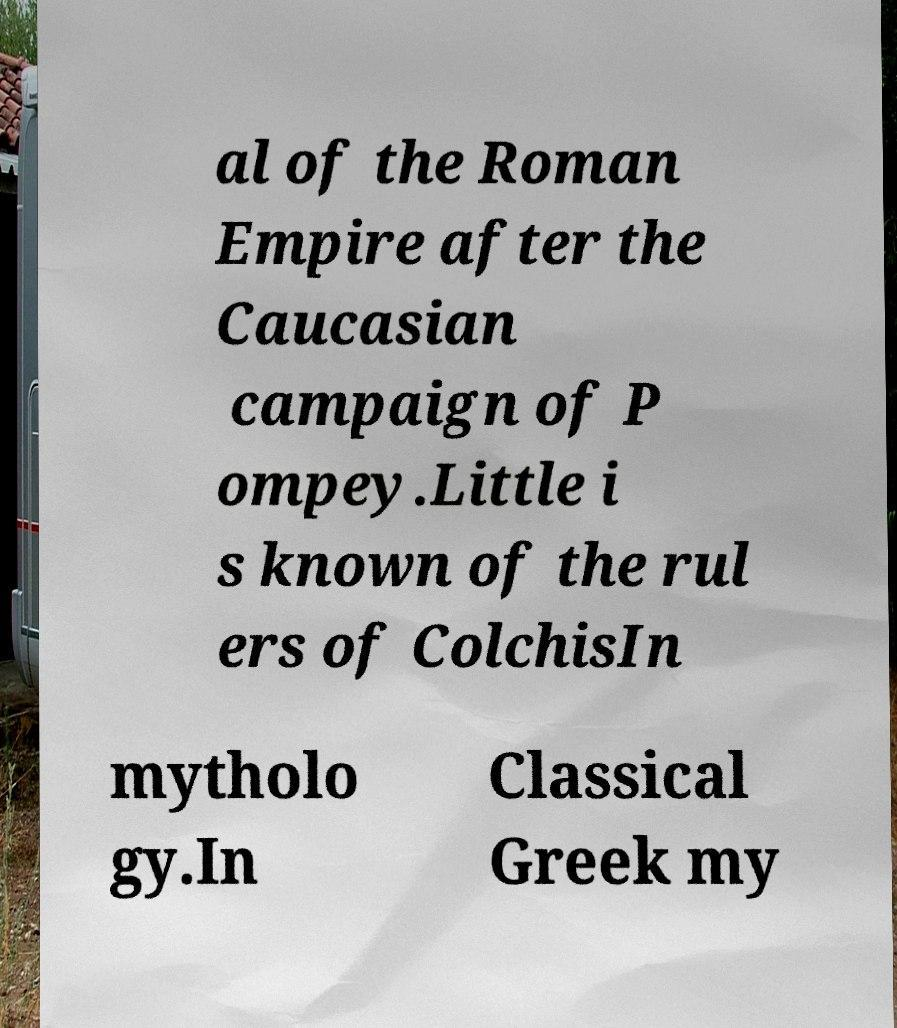Can you accurately transcribe the text from the provided image for me? al of the Roman Empire after the Caucasian campaign of P ompey.Little i s known of the rul ers of ColchisIn mytholo gy.In Classical Greek my 